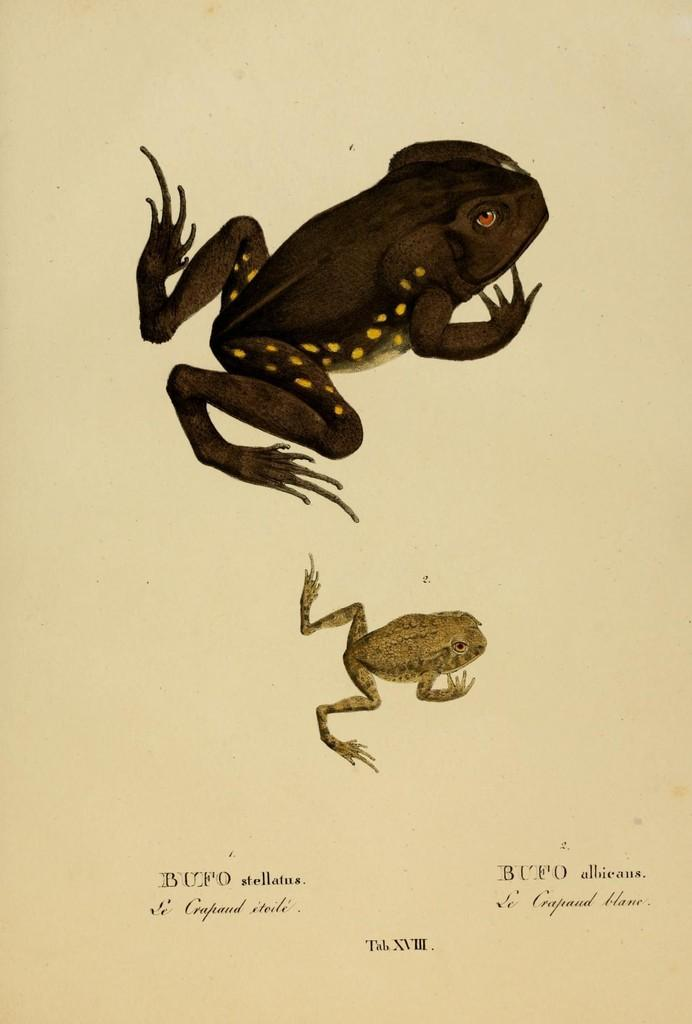What is present in the image related to visual communication? There is a poster in the image. What can be found on the poster? The poster contains images and text. What type of hospital is depicted in the poster? There is no hospital depicted in the poster; it contains images and text unrelated to a hospital. 